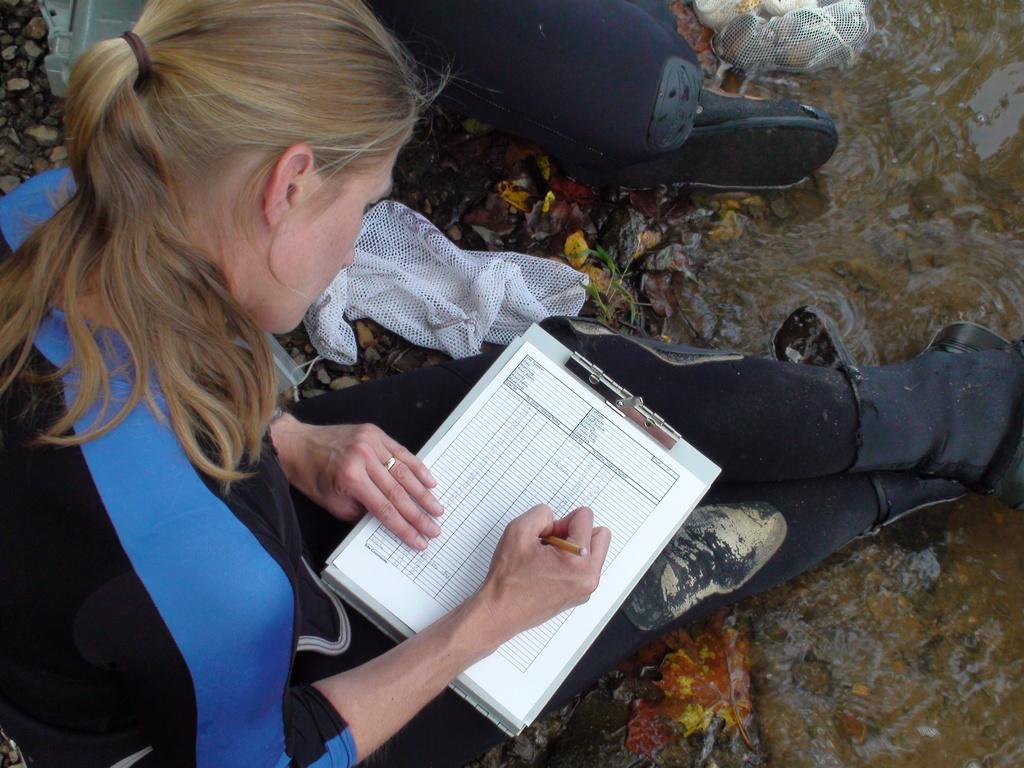In one or two sentences, can you explain what this image depicts? In the image in the center, we can see one woman sitting and writing something on the paper. In the background there is a blanket, one cloth and a few other objects. 